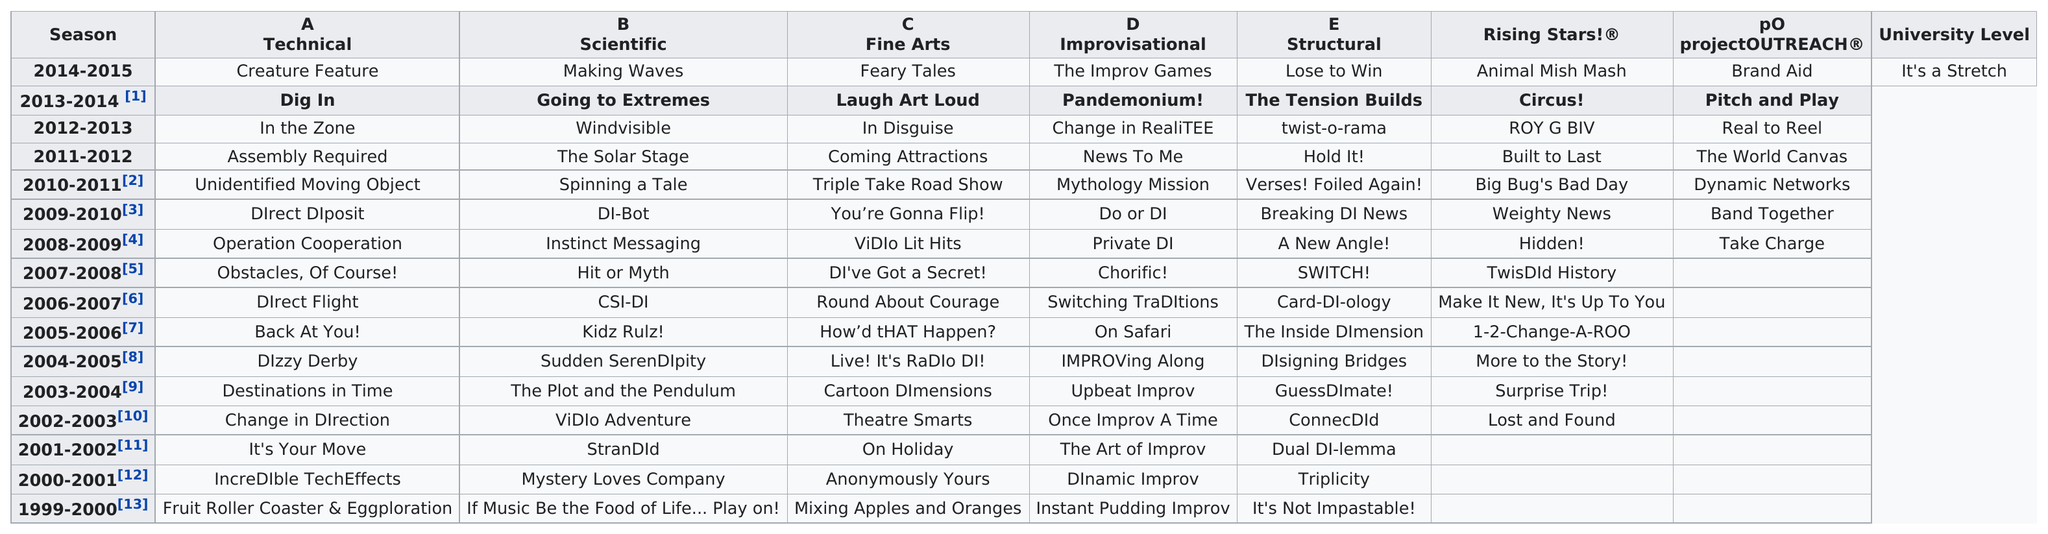List a handful of essential elements in this visual. The last set of years listed is 1999-2000. After the solar stage, the challenge for science was to discover the invisible wind. The largest year listed is 2014-2015. The technical challenge that followed "direct disposal" was "Unidentified Moving Object. The earliest technical challenge title was "Fruit Roller Coaster & Eggploration. 